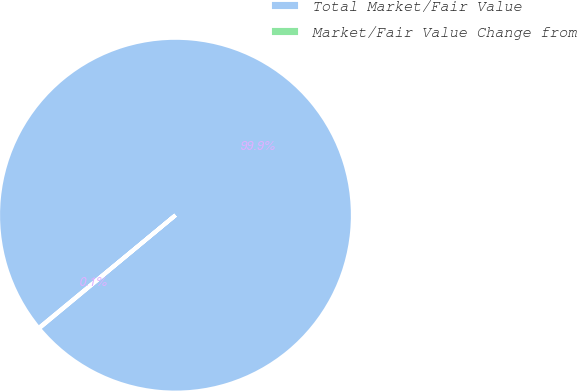Convert chart. <chart><loc_0><loc_0><loc_500><loc_500><pie_chart><fcel>Total Market/Fair Value<fcel>Market/Fair Value Change from<nl><fcel>99.95%<fcel>0.05%<nl></chart> 